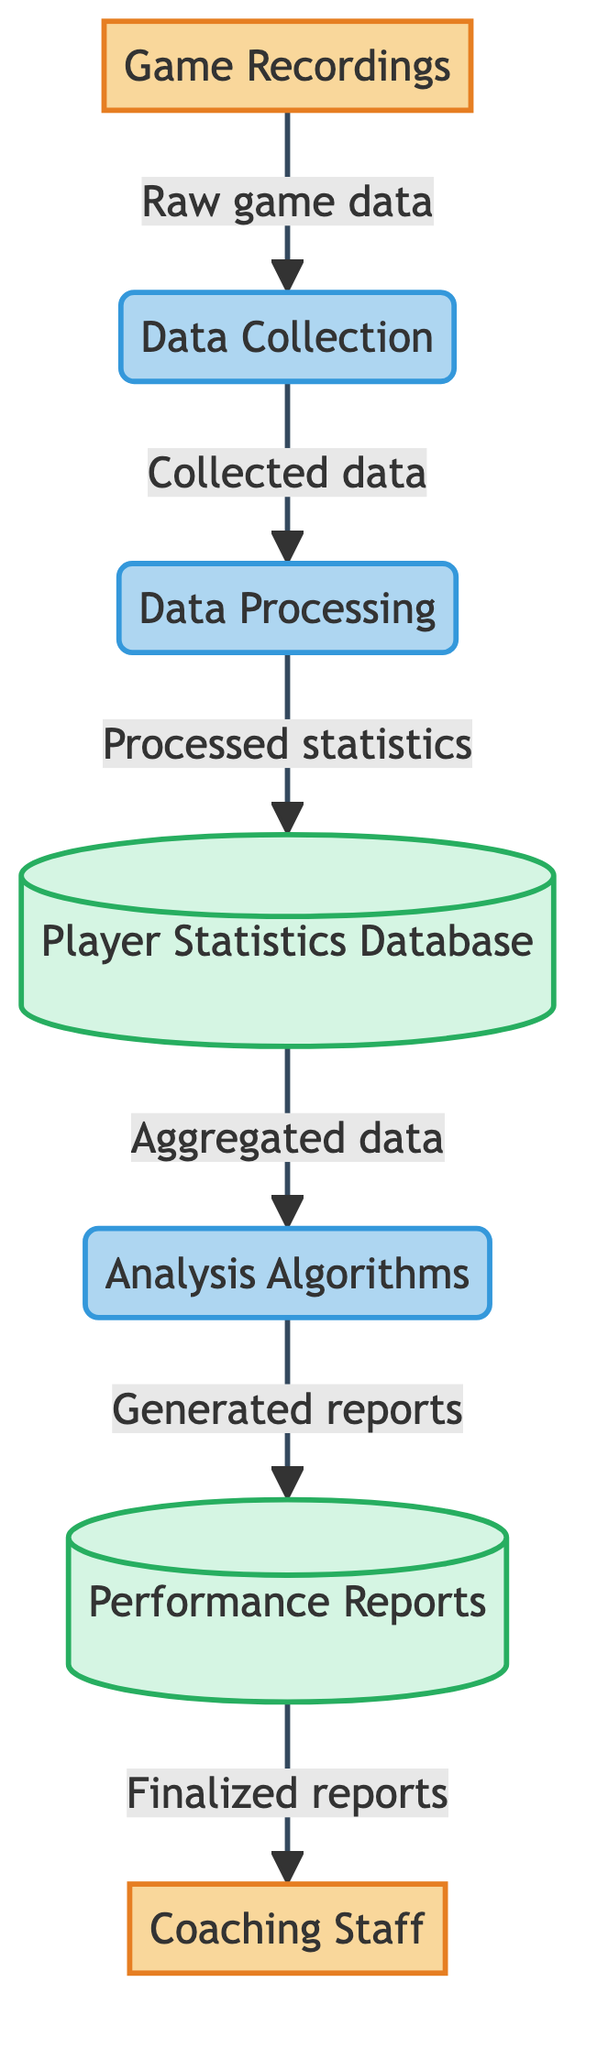What is the first entity in the diagram? The first entity is "Game Recordings," which serves as the source of raw game data for the data flow.
Answer: Game Recordings How many processes are in the diagram? The diagram has three processes: Data Collection, Data Processing, and Analysis Algorithms, totaling to three processes in the flow.
Answer: 3 Which entity receives the processed statistics? The "Player Statistics Database" receives the processed statistics as it stores the cleaned player performance data.
Answer: Player Statistics Database What type of data is stored in the Performance Reports? The "Performance Reports" store generated reports based on analyzed data, which focus on player performance metrics.
Answer: Generated reports Which external entity utilizes the Performance Reports? The "Coaching Staff" utilizes the Performance Reports to make strategic decisions regarding the team's performance.
Answer: Coaching Staff What is the flow from Data Processing to Player Statistics Database? The flow from Data Processing to Player Statistics Database is described as "Processed statistics," indicating the output of the data processing step.
Answer: Processed statistics What process comes after Data Collection in the flow? The process that follows Data Collection is Data Processing, which is responsible for cleaning and extracting relevant metrics from the collected data.
Answer: Data Processing What is the relationship between Analysis Algorithms and Performance Reports? The Analysis Algorithms generate reports that are then stored in the Performance Reports data store, indicating a forward flow from analysis to reporting.
Answer: Generated reports How many data stores are depicted in the diagram? There are two data stores in the diagram: Player Statistics Database and Performance Reports, indicating where the data is kept and accessed.
Answer: 2 